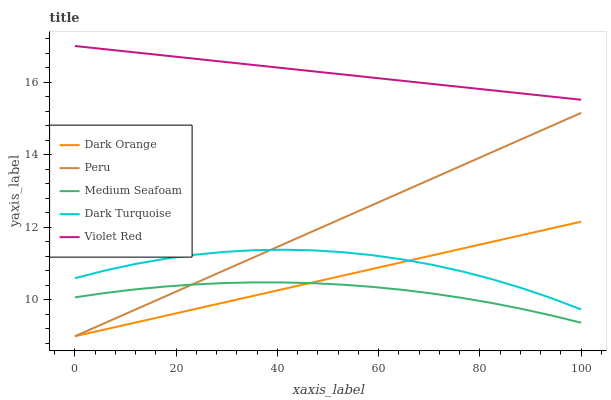Does Violet Red have the minimum area under the curve?
Answer yes or no. No. Does Medium Seafoam have the maximum area under the curve?
Answer yes or no. No. Is Medium Seafoam the smoothest?
Answer yes or no. No. Is Medium Seafoam the roughest?
Answer yes or no. No. Does Medium Seafoam have the lowest value?
Answer yes or no. No. Does Medium Seafoam have the highest value?
Answer yes or no. No. Is Medium Seafoam less than Violet Red?
Answer yes or no. Yes. Is Violet Red greater than Dark Orange?
Answer yes or no. Yes. Does Medium Seafoam intersect Violet Red?
Answer yes or no. No. 